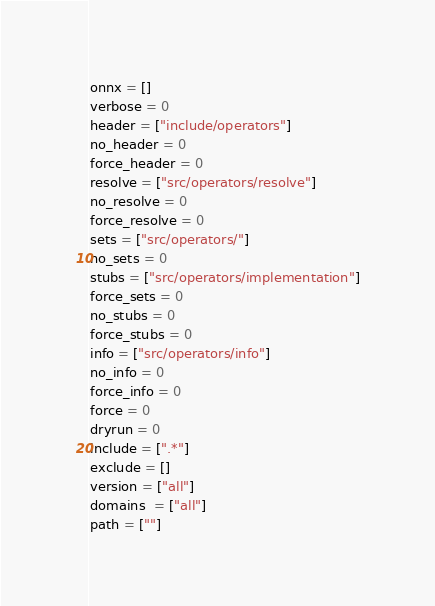<code> <loc_0><loc_0><loc_500><loc_500><_Python_>
onnx = []
verbose = 0
header = ["include/operators"]
no_header = 0
force_header = 0
resolve = ["src/operators/resolve"]
no_resolve = 0
force_resolve = 0
sets = ["src/operators/"]
no_sets = 0
stubs = ["src/operators/implementation"]
force_sets = 0
no_stubs = 0
force_stubs = 0
info = ["src/operators/info"]
no_info = 0
force_info = 0
force = 0
dryrun = 0
include = [".*"]
exclude = []
version = ["all"]
domains  = ["all"]
path = [""]</code> 